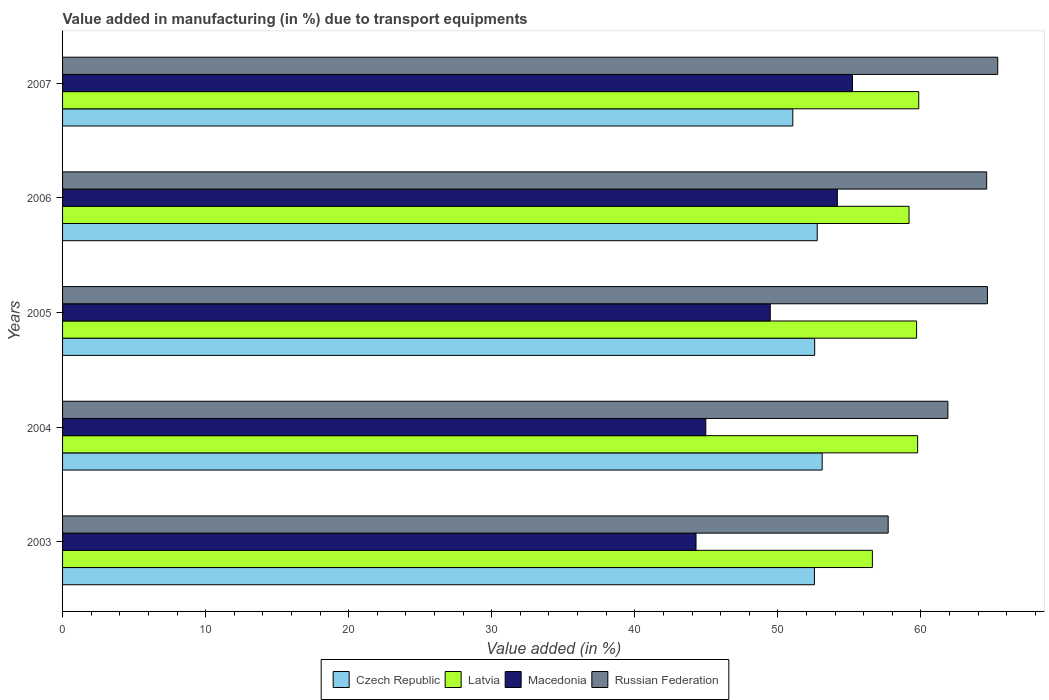How many different coloured bars are there?
Make the answer very short. 4. How many bars are there on the 2nd tick from the top?
Give a very brief answer. 4. How many bars are there on the 4th tick from the bottom?
Your response must be concise. 4. What is the label of the 2nd group of bars from the top?
Provide a succinct answer. 2006. What is the percentage of value added in manufacturing due to transport equipments in Russian Federation in 2005?
Make the answer very short. 64.65. Across all years, what is the maximum percentage of value added in manufacturing due to transport equipments in Russian Federation?
Your answer should be compact. 65.37. Across all years, what is the minimum percentage of value added in manufacturing due to transport equipments in Macedonia?
Your response must be concise. 44.28. In which year was the percentage of value added in manufacturing due to transport equipments in Czech Republic maximum?
Ensure brevity in your answer.  2004. In which year was the percentage of value added in manufacturing due to transport equipments in Russian Federation minimum?
Offer a very short reply. 2003. What is the total percentage of value added in manufacturing due to transport equipments in Russian Federation in the graph?
Provide a succinct answer. 314.21. What is the difference between the percentage of value added in manufacturing due to transport equipments in Russian Federation in 2003 and that in 2005?
Your answer should be compact. -6.94. What is the difference between the percentage of value added in manufacturing due to transport equipments in Russian Federation in 2005 and the percentage of value added in manufacturing due to transport equipments in Macedonia in 2003?
Ensure brevity in your answer.  20.37. What is the average percentage of value added in manufacturing due to transport equipments in Latvia per year?
Keep it short and to the point. 59.02. In the year 2007, what is the difference between the percentage of value added in manufacturing due to transport equipments in Russian Federation and percentage of value added in manufacturing due to transport equipments in Czech Republic?
Your response must be concise. 14.32. What is the ratio of the percentage of value added in manufacturing due to transport equipments in Czech Republic in 2005 to that in 2007?
Ensure brevity in your answer.  1.03. Is the percentage of value added in manufacturing due to transport equipments in Czech Republic in 2005 less than that in 2006?
Your response must be concise. Yes. Is the difference between the percentage of value added in manufacturing due to transport equipments in Russian Federation in 2006 and 2007 greater than the difference between the percentage of value added in manufacturing due to transport equipments in Czech Republic in 2006 and 2007?
Give a very brief answer. No. What is the difference between the highest and the second highest percentage of value added in manufacturing due to transport equipments in Czech Republic?
Your answer should be compact. 0.35. What is the difference between the highest and the lowest percentage of value added in manufacturing due to transport equipments in Czech Republic?
Ensure brevity in your answer.  2.05. Is the sum of the percentage of value added in manufacturing due to transport equipments in Latvia in 2003 and 2006 greater than the maximum percentage of value added in manufacturing due to transport equipments in Czech Republic across all years?
Ensure brevity in your answer.  Yes. What does the 4th bar from the top in 2003 represents?
Your answer should be very brief. Czech Republic. What does the 4th bar from the bottom in 2006 represents?
Your answer should be compact. Russian Federation. Is it the case that in every year, the sum of the percentage of value added in manufacturing due to transport equipments in Latvia and percentage of value added in manufacturing due to transport equipments in Russian Federation is greater than the percentage of value added in manufacturing due to transport equipments in Macedonia?
Offer a terse response. Yes. How many bars are there?
Offer a very short reply. 20. Are all the bars in the graph horizontal?
Offer a terse response. Yes. What is the difference between two consecutive major ticks on the X-axis?
Ensure brevity in your answer.  10. Does the graph contain any zero values?
Your answer should be very brief. No. Does the graph contain grids?
Offer a terse response. No. Where does the legend appear in the graph?
Your answer should be very brief. Bottom center. What is the title of the graph?
Your answer should be very brief. Value added in manufacturing (in %) due to transport equipments. Does "Liechtenstein" appear as one of the legend labels in the graph?
Ensure brevity in your answer.  No. What is the label or title of the X-axis?
Your response must be concise. Value added (in %). What is the Value added (in %) of Czech Republic in 2003?
Provide a succinct answer. 52.56. What is the Value added (in %) of Latvia in 2003?
Your answer should be compact. 56.61. What is the Value added (in %) of Macedonia in 2003?
Make the answer very short. 44.28. What is the Value added (in %) in Russian Federation in 2003?
Provide a succinct answer. 57.71. What is the Value added (in %) of Czech Republic in 2004?
Ensure brevity in your answer.  53.1. What is the Value added (in %) of Latvia in 2004?
Make the answer very short. 59.77. What is the Value added (in %) in Macedonia in 2004?
Give a very brief answer. 44.96. What is the Value added (in %) in Russian Federation in 2004?
Offer a terse response. 61.89. What is the Value added (in %) of Czech Republic in 2005?
Offer a very short reply. 52.57. What is the Value added (in %) of Latvia in 2005?
Offer a very short reply. 59.7. What is the Value added (in %) in Macedonia in 2005?
Your answer should be compact. 49.47. What is the Value added (in %) of Russian Federation in 2005?
Offer a very short reply. 64.65. What is the Value added (in %) in Czech Republic in 2006?
Ensure brevity in your answer.  52.75. What is the Value added (in %) of Latvia in 2006?
Offer a very short reply. 59.17. What is the Value added (in %) in Macedonia in 2006?
Your answer should be very brief. 54.16. What is the Value added (in %) in Russian Federation in 2006?
Keep it short and to the point. 64.59. What is the Value added (in %) in Czech Republic in 2007?
Ensure brevity in your answer.  51.04. What is the Value added (in %) of Latvia in 2007?
Ensure brevity in your answer.  59.85. What is the Value added (in %) in Macedonia in 2007?
Provide a succinct answer. 55.21. What is the Value added (in %) of Russian Federation in 2007?
Give a very brief answer. 65.37. Across all years, what is the maximum Value added (in %) of Czech Republic?
Offer a terse response. 53.1. Across all years, what is the maximum Value added (in %) in Latvia?
Provide a succinct answer. 59.85. Across all years, what is the maximum Value added (in %) in Macedonia?
Provide a short and direct response. 55.21. Across all years, what is the maximum Value added (in %) in Russian Federation?
Make the answer very short. 65.37. Across all years, what is the minimum Value added (in %) in Czech Republic?
Make the answer very short. 51.04. Across all years, what is the minimum Value added (in %) in Latvia?
Offer a terse response. 56.61. Across all years, what is the minimum Value added (in %) in Macedonia?
Offer a very short reply. 44.28. Across all years, what is the minimum Value added (in %) of Russian Federation?
Offer a very short reply. 57.71. What is the total Value added (in %) in Czech Republic in the graph?
Give a very brief answer. 262.02. What is the total Value added (in %) of Latvia in the graph?
Provide a short and direct response. 295.09. What is the total Value added (in %) in Macedonia in the graph?
Give a very brief answer. 248.08. What is the total Value added (in %) of Russian Federation in the graph?
Your answer should be very brief. 314.21. What is the difference between the Value added (in %) of Czech Republic in 2003 and that in 2004?
Make the answer very short. -0.54. What is the difference between the Value added (in %) of Latvia in 2003 and that in 2004?
Offer a terse response. -3.16. What is the difference between the Value added (in %) in Macedonia in 2003 and that in 2004?
Provide a short and direct response. -0.68. What is the difference between the Value added (in %) in Russian Federation in 2003 and that in 2004?
Make the answer very short. -4.18. What is the difference between the Value added (in %) in Czech Republic in 2003 and that in 2005?
Give a very brief answer. -0.02. What is the difference between the Value added (in %) of Latvia in 2003 and that in 2005?
Keep it short and to the point. -3.09. What is the difference between the Value added (in %) of Macedonia in 2003 and that in 2005?
Provide a short and direct response. -5.19. What is the difference between the Value added (in %) in Russian Federation in 2003 and that in 2005?
Keep it short and to the point. -6.94. What is the difference between the Value added (in %) in Czech Republic in 2003 and that in 2006?
Ensure brevity in your answer.  -0.19. What is the difference between the Value added (in %) in Latvia in 2003 and that in 2006?
Ensure brevity in your answer.  -2.56. What is the difference between the Value added (in %) of Macedonia in 2003 and that in 2006?
Provide a short and direct response. -9.88. What is the difference between the Value added (in %) in Russian Federation in 2003 and that in 2006?
Offer a very short reply. -6.88. What is the difference between the Value added (in %) of Czech Republic in 2003 and that in 2007?
Keep it short and to the point. 1.51. What is the difference between the Value added (in %) in Latvia in 2003 and that in 2007?
Provide a succinct answer. -3.24. What is the difference between the Value added (in %) in Macedonia in 2003 and that in 2007?
Give a very brief answer. -10.93. What is the difference between the Value added (in %) in Russian Federation in 2003 and that in 2007?
Give a very brief answer. -7.66. What is the difference between the Value added (in %) of Czech Republic in 2004 and that in 2005?
Your answer should be compact. 0.52. What is the difference between the Value added (in %) in Latvia in 2004 and that in 2005?
Your response must be concise. 0.07. What is the difference between the Value added (in %) in Macedonia in 2004 and that in 2005?
Make the answer very short. -4.51. What is the difference between the Value added (in %) of Russian Federation in 2004 and that in 2005?
Ensure brevity in your answer.  -2.76. What is the difference between the Value added (in %) in Czech Republic in 2004 and that in 2006?
Ensure brevity in your answer.  0.35. What is the difference between the Value added (in %) in Latvia in 2004 and that in 2006?
Provide a succinct answer. 0.6. What is the difference between the Value added (in %) of Macedonia in 2004 and that in 2006?
Offer a very short reply. -9.19. What is the difference between the Value added (in %) in Russian Federation in 2004 and that in 2006?
Provide a short and direct response. -2.71. What is the difference between the Value added (in %) of Czech Republic in 2004 and that in 2007?
Your response must be concise. 2.05. What is the difference between the Value added (in %) in Latvia in 2004 and that in 2007?
Give a very brief answer. -0.08. What is the difference between the Value added (in %) of Macedonia in 2004 and that in 2007?
Make the answer very short. -10.25. What is the difference between the Value added (in %) of Russian Federation in 2004 and that in 2007?
Offer a terse response. -3.48. What is the difference between the Value added (in %) of Czech Republic in 2005 and that in 2006?
Offer a very short reply. -0.18. What is the difference between the Value added (in %) of Latvia in 2005 and that in 2006?
Your answer should be very brief. 0.53. What is the difference between the Value added (in %) of Macedonia in 2005 and that in 2006?
Give a very brief answer. -4.69. What is the difference between the Value added (in %) in Russian Federation in 2005 and that in 2006?
Offer a very short reply. 0.05. What is the difference between the Value added (in %) of Czech Republic in 2005 and that in 2007?
Provide a succinct answer. 1.53. What is the difference between the Value added (in %) in Macedonia in 2005 and that in 2007?
Offer a very short reply. -5.75. What is the difference between the Value added (in %) in Russian Federation in 2005 and that in 2007?
Your answer should be compact. -0.72. What is the difference between the Value added (in %) of Czech Republic in 2006 and that in 2007?
Offer a terse response. 1.71. What is the difference between the Value added (in %) in Latvia in 2006 and that in 2007?
Your answer should be compact. -0.68. What is the difference between the Value added (in %) of Macedonia in 2006 and that in 2007?
Make the answer very short. -1.06. What is the difference between the Value added (in %) in Russian Federation in 2006 and that in 2007?
Provide a succinct answer. -0.77. What is the difference between the Value added (in %) in Czech Republic in 2003 and the Value added (in %) in Latvia in 2004?
Your response must be concise. -7.21. What is the difference between the Value added (in %) of Czech Republic in 2003 and the Value added (in %) of Macedonia in 2004?
Ensure brevity in your answer.  7.59. What is the difference between the Value added (in %) in Czech Republic in 2003 and the Value added (in %) in Russian Federation in 2004?
Make the answer very short. -9.33. What is the difference between the Value added (in %) of Latvia in 2003 and the Value added (in %) of Macedonia in 2004?
Ensure brevity in your answer.  11.64. What is the difference between the Value added (in %) of Latvia in 2003 and the Value added (in %) of Russian Federation in 2004?
Make the answer very short. -5.28. What is the difference between the Value added (in %) of Macedonia in 2003 and the Value added (in %) of Russian Federation in 2004?
Your answer should be very brief. -17.61. What is the difference between the Value added (in %) in Czech Republic in 2003 and the Value added (in %) in Latvia in 2005?
Make the answer very short. -7.14. What is the difference between the Value added (in %) in Czech Republic in 2003 and the Value added (in %) in Macedonia in 2005?
Provide a short and direct response. 3.09. What is the difference between the Value added (in %) of Czech Republic in 2003 and the Value added (in %) of Russian Federation in 2005?
Provide a short and direct response. -12.09. What is the difference between the Value added (in %) of Latvia in 2003 and the Value added (in %) of Macedonia in 2005?
Give a very brief answer. 7.14. What is the difference between the Value added (in %) in Latvia in 2003 and the Value added (in %) in Russian Federation in 2005?
Offer a very short reply. -8.04. What is the difference between the Value added (in %) in Macedonia in 2003 and the Value added (in %) in Russian Federation in 2005?
Offer a very short reply. -20.37. What is the difference between the Value added (in %) of Czech Republic in 2003 and the Value added (in %) of Latvia in 2006?
Your answer should be compact. -6.61. What is the difference between the Value added (in %) of Czech Republic in 2003 and the Value added (in %) of Macedonia in 2006?
Provide a succinct answer. -1.6. What is the difference between the Value added (in %) of Czech Republic in 2003 and the Value added (in %) of Russian Federation in 2006?
Offer a terse response. -12.04. What is the difference between the Value added (in %) in Latvia in 2003 and the Value added (in %) in Macedonia in 2006?
Your answer should be compact. 2.45. What is the difference between the Value added (in %) in Latvia in 2003 and the Value added (in %) in Russian Federation in 2006?
Your response must be concise. -7.99. What is the difference between the Value added (in %) in Macedonia in 2003 and the Value added (in %) in Russian Federation in 2006?
Your answer should be compact. -20.32. What is the difference between the Value added (in %) of Czech Republic in 2003 and the Value added (in %) of Latvia in 2007?
Your answer should be compact. -7.29. What is the difference between the Value added (in %) in Czech Republic in 2003 and the Value added (in %) in Macedonia in 2007?
Keep it short and to the point. -2.66. What is the difference between the Value added (in %) of Czech Republic in 2003 and the Value added (in %) of Russian Federation in 2007?
Your answer should be very brief. -12.81. What is the difference between the Value added (in %) in Latvia in 2003 and the Value added (in %) in Macedonia in 2007?
Give a very brief answer. 1.39. What is the difference between the Value added (in %) of Latvia in 2003 and the Value added (in %) of Russian Federation in 2007?
Offer a very short reply. -8.76. What is the difference between the Value added (in %) of Macedonia in 2003 and the Value added (in %) of Russian Federation in 2007?
Make the answer very short. -21.09. What is the difference between the Value added (in %) in Czech Republic in 2004 and the Value added (in %) in Latvia in 2005?
Keep it short and to the point. -6.6. What is the difference between the Value added (in %) in Czech Republic in 2004 and the Value added (in %) in Macedonia in 2005?
Your answer should be compact. 3.63. What is the difference between the Value added (in %) of Czech Republic in 2004 and the Value added (in %) of Russian Federation in 2005?
Keep it short and to the point. -11.55. What is the difference between the Value added (in %) in Latvia in 2004 and the Value added (in %) in Macedonia in 2005?
Keep it short and to the point. 10.3. What is the difference between the Value added (in %) of Latvia in 2004 and the Value added (in %) of Russian Federation in 2005?
Ensure brevity in your answer.  -4.88. What is the difference between the Value added (in %) in Macedonia in 2004 and the Value added (in %) in Russian Federation in 2005?
Make the answer very short. -19.68. What is the difference between the Value added (in %) of Czech Republic in 2004 and the Value added (in %) of Latvia in 2006?
Keep it short and to the point. -6.07. What is the difference between the Value added (in %) of Czech Republic in 2004 and the Value added (in %) of Macedonia in 2006?
Your answer should be very brief. -1.06. What is the difference between the Value added (in %) in Czech Republic in 2004 and the Value added (in %) in Russian Federation in 2006?
Offer a very short reply. -11.5. What is the difference between the Value added (in %) in Latvia in 2004 and the Value added (in %) in Macedonia in 2006?
Offer a very short reply. 5.61. What is the difference between the Value added (in %) of Latvia in 2004 and the Value added (in %) of Russian Federation in 2006?
Your answer should be very brief. -4.83. What is the difference between the Value added (in %) in Macedonia in 2004 and the Value added (in %) in Russian Federation in 2006?
Keep it short and to the point. -19.63. What is the difference between the Value added (in %) in Czech Republic in 2004 and the Value added (in %) in Latvia in 2007?
Your answer should be compact. -6.75. What is the difference between the Value added (in %) in Czech Republic in 2004 and the Value added (in %) in Macedonia in 2007?
Offer a very short reply. -2.12. What is the difference between the Value added (in %) of Czech Republic in 2004 and the Value added (in %) of Russian Federation in 2007?
Offer a terse response. -12.27. What is the difference between the Value added (in %) of Latvia in 2004 and the Value added (in %) of Macedonia in 2007?
Offer a very short reply. 4.56. What is the difference between the Value added (in %) in Latvia in 2004 and the Value added (in %) in Russian Federation in 2007?
Your answer should be compact. -5.6. What is the difference between the Value added (in %) of Macedonia in 2004 and the Value added (in %) of Russian Federation in 2007?
Make the answer very short. -20.41. What is the difference between the Value added (in %) in Czech Republic in 2005 and the Value added (in %) in Latvia in 2006?
Your response must be concise. -6.6. What is the difference between the Value added (in %) in Czech Republic in 2005 and the Value added (in %) in Macedonia in 2006?
Your response must be concise. -1.58. What is the difference between the Value added (in %) in Czech Republic in 2005 and the Value added (in %) in Russian Federation in 2006?
Offer a very short reply. -12.02. What is the difference between the Value added (in %) of Latvia in 2005 and the Value added (in %) of Macedonia in 2006?
Your response must be concise. 5.54. What is the difference between the Value added (in %) of Latvia in 2005 and the Value added (in %) of Russian Federation in 2006?
Provide a succinct answer. -4.9. What is the difference between the Value added (in %) in Macedonia in 2005 and the Value added (in %) in Russian Federation in 2006?
Provide a short and direct response. -15.13. What is the difference between the Value added (in %) in Czech Republic in 2005 and the Value added (in %) in Latvia in 2007?
Provide a succinct answer. -7.27. What is the difference between the Value added (in %) in Czech Republic in 2005 and the Value added (in %) in Macedonia in 2007?
Give a very brief answer. -2.64. What is the difference between the Value added (in %) in Czech Republic in 2005 and the Value added (in %) in Russian Federation in 2007?
Keep it short and to the point. -12.79. What is the difference between the Value added (in %) of Latvia in 2005 and the Value added (in %) of Macedonia in 2007?
Ensure brevity in your answer.  4.48. What is the difference between the Value added (in %) of Latvia in 2005 and the Value added (in %) of Russian Federation in 2007?
Your answer should be very brief. -5.67. What is the difference between the Value added (in %) of Macedonia in 2005 and the Value added (in %) of Russian Federation in 2007?
Keep it short and to the point. -15.9. What is the difference between the Value added (in %) of Czech Republic in 2006 and the Value added (in %) of Latvia in 2007?
Your answer should be compact. -7.1. What is the difference between the Value added (in %) of Czech Republic in 2006 and the Value added (in %) of Macedonia in 2007?
Make the answer very short. -2.46. What is the difference between the Value added (in %) of Czech Republic in 2006 and the Value added (in %) of Russian Federation in 2007?
Provide a succinct answer. -12.62. What is the difference between the Value added (in %) of Latvia in 2006 and the Value added (in %) of Macedonia in 2007?
Your response must be concise. 3.96. What is the difference between the Value added (in %) of Latvia in 2006 and the Value added (in %) of Russian Federation in 2007?
Make the answer very short. -6.2. What is the difference between the Value added (in %) of Macedonia in 2006 and the Value added (in %) of Russian Federation in 2007?
Keep it short and to the point. -11.21. What is the average Value added (in %) in Czech Republic per year?
Your answer should be very brief. 52.4. What is the average Value added (in %) of Latvia per year?
Ensure brevity in your answer.  59.02. What is the average Value added (in %) in Macedonia per year?
Ensure brevity in your answer.  49.62. What is the average Value added (in %) of Russian Federation per year?
Make the answer very short. 62.84. In the year 2003, what is the difference between the Value added (in %) in Czech Republic and Value added (in %) in Latvia?
Provide a short and direct response. -4.05. In the year 2003, what is the difference between the Value added (in %) of Czech Republic and Value added (in %) of Macedonia?
Make the answer very short. 8.28. In the year 2003, what is the difference between the Value added (in %) of Czech Republic and Value added (in %) of Russian Federation?
Keep it short and to the point. -5.15. In the year 2003, what is the difference between the Value added (in %) of Latvia and Value added (in %) of Macedonia?
Your answer should be very brief. 12.33. In the year 2003, what is the difference between the Value added (in %) in Latvia and Value added (in %) in Russian Federation?
Offer a very short reply. -1.1. In the year 2003, what is the difference between the Value added (in %) of Macedonia and Value added (in %) of Russian Federation?
Offer a very short reply. -13.43. In the year 2004, what is the difference between the Value added (in %) of Czech Republic and Value added (in %) of Latvia?
Provide a succinct answer. -6.67. In the year 2004, what is the difference between the Value added (in %) of Czech Republic and Value added (in %) of Macedonia?
Your answer should be compact. 8.13. In the year 2004, what is the difference between the Value added (in %) in Czech Republic and Value added (in %) in Russian Federation?
Your answer should be very brief. -8.79. In the year 2004, what is the difference between the Value added (in %) of Latvia and Value added (in %) of Macedonia?
Make the answer very short. 14.81. In the year 2004, what is the difference between the Value added (in %) in Latvia and Value added (in %) in Russian Federation?
Make the answer very short. -2.12. In the year 2004, what is the difference between the Value added (in %) of Macedonia and Value added (in %) of Russian Federation?
Provide a short and direct response. -16.92. In the year 2005, what is the difference between the Value added (in %) of Czech Republic and Value added (in %) of Latvia?
Keep it short and to the point. -7.12. In the year 2005, what is the difference between the Value added (in %) in Czech Republic and Value added (in %) in Macedonia?
Offer a very short reply. 3.11. In the year 2005, what is the difference between the Value added (in %) of Czech Republic and Value added (in %) of Russian Federation?
Offer a terse response. -12.07. In the year 2005, what is the difference between the Value added (in %) in Latvia and Value added (in %) in Macedonia?
Your answer should be compact. 10.23. In the year 2005, what is the difference between the Value added (in %) in Latvia and Value added (in %) in Russian Federation?
Provide a succinct answer. -4.95. In the year 2005, what is the difference between the Value added (in %) of Macedonia and Value added (in %) of Russian Federation?
Offer a very short reply. -15.18. In the year 2006, what is the difference between the Value added (in %) in Czech Republic and Value added (in %) in Latvia?
Offer a very short reply. -6.42. In the year 2006, what is the difference between the Value added (in %) of Czech Republic and Value added (in %) of Macedonia?
Your answer should be compact. -1.41. In the year 2006, what is the difference between the Value added (in %) in Czech Republic and Value added (in %) in Russian Federation?
Make the answer very short. -11.85. In the year 2006, what is the difference between the Value added (in %) in Latvia and Value added (in %) in Macedonia?
Ensure brevity in your answer.  5.01. In the year 2006, what is the difference between the Value added (in %) of Latvia and Value added (in %) of Russian Federation?
Make the answer very short. -5.43. In the year 2006, what is the difference between the Value added (in %) in Macedonia and Value added (in %) in Russian Federation?
Your answer should be compact. -10.44. In the year 2007, what is the difference between the Value added (in %) of Czech Republic and Value added (in %) of Latvia?
Your answer should be very brief. -8.8. In the year 2007, what is the difference between the Value added (in %) in Czech Republic and Value added (in %) in Macedonia?
Provide a short and direct response. -4.17. In the year 2007, what is the difference between the Value added (in %) in Czech Republic and Value added (in %) in Russian Federation?
Your answer should be very brief. -14.32. In the year 2007, what is the difference between the Value added (in %) in Latvia and Value added (in %) in Macedonia?
Offer a terse response. 4.63. In the year 2007, what is the difference between the Value added (in %) of Latvia and Value added (in %) of Russian Federation?
Make the answer very short. -5.52. In the year 2007, what is the difference between the Value added (in %) in Macedonia and Value added (in %) in Russian Federation?
Provide a succinct answer. -10.15. What is the ratio of the Value added (in %) of Latvia in 2003 to that in 2004?
Offer a terse response. 0.95. What is the ratio of the Value added (in %) in Macedonia in 2003 to that in 2004?
Provide a succinct answer. 0.98. What is the ratio of the Value added (in %) of Russian Federation in 2003 to that in 2004?
Your response must be concise. 0.93. What is the ratio of the Value added (in %) in Latvia in 2003 to that in 2005?
Offer a terse response. 0.95. What is the ratio of the Value added (in %) in Macedonia in 2003 to that in 2005?
Ensure brevity in your answer.  0.9. What is the ratio of the Value added (in %) in Russian Federation in 2003 to that in 2005?
Ensure brevity in your answer.  0.89. What is the ratio of the Value added (in %) of Czech Republic in 2003 to that in 2006?
Give a very brief answer. 1. What is the ratio of the Value added (in %) in Latvia in 2003 to that in 2006?
Keep it short and to the point. 0.96. What is the ratio of the Value added (in %) of Macedonia in 2003 to that in 2006?
Your answer should be very brief. 0.82. What is the ratio of the Value added (in %) in Russian Federation in 2003 to that in 2006?
Your answer should be compact. 0.89. What is the ratio of the Value added (in %) of Czech Republic in 2003 to that in 2007?
Offer a terse response. 1.03. What is the ratio of the Value added (in %) of Latvia in 2003 to that in 2007?
Your response must be concise. 0.95. What is the ratio of the Value added (in %) of Macedonia in 2003 to that in 2007?
Your answer should be very brief. 0.8. What is the ratio of the Value added (in %) of Russian Federation in 2003 to that in 2007?
Your answer should be very brief. 0.88. What is the ratio of the Value added (in %) in Latvia in 2004 to that in 2005?
Offer a very short reply. 1. What is the ratio of the Value added (in %) in Macedonia in 2004 to that in 2005?
Provide a succinct answer. 0.91. What is the ratio of the Value added (in %) of Russian Federation in 2004 to that in 2005?
Make the answer very short. 0.96. What is the ratio of the Value added (in %) in Czech Republic in 2004 to that in 2006?
Provide a succinct answer. 1.01. What is the ratio of the Value added (in %) in Latvia in 2004 to that in 2006?
Your answer should be compact. 1.01. What is the ratio of the Value added (in %) of Macedonia in 2004 to that in 2006?
Your response must be concise. 0.83. What is the ratio of the Value added (in %) in Russian Federation in 2004 to that in 2006?
Provide a succinct answer. 0.96. What is the ratio of the Value added (in %) of Czech Republic in 2004 to that in 2007?
Your response must be concise. 1.04. What is the ratio of the Value added (in %) of Macedonia in 2004 to that in 2007?
Ensure brevity in your answer.  0.81. What is the ratio of the Value added (in %) in Russian Federation in 2004 to that in 2007?
Provide a succinct answer. 0.95. What is the ratio of the Value added (in %) in Latvia in 2005 to that in 2006?
Provide a succinct answer. 1.01. What is the ratio of the Value added (in %) of Macedonia in 2005 to that in 2006?
Your answer should be compact. 0.91. What is the ratio of the Value added (in %) of Russian Federation in 2005 to that in 2006?
Offer a very short reply. 1. What is the ratio of the Value added (in %) in Latvia in 2005 to that in 2007?
Offer a very short reply. 1. What is the ratio of the Value added (in %) of Macedonia in 2005 to that in 2007?
Your answer should be very brief. 0.9. What is the ratio of the Value added (in %) of Czech Republic in 2006 to that in 2007?
Offer a very short reply. 1.03. What is the ratio of the Value added (in %) in Latvia in 2006 to that in 2007?
Your response must be concise. 0.99. What is the ratio of the Value added (in %) of Macedonia in 2006 to that in 2007?
Make the answer very short. 0.98. What is the difference between the highest and the second highest Value added (in %) in Czech Republic?
Your answer should be compact. 0.35. What is the difference between the highest and the second highest Value added (in %) of Latvia?
Your answer should be compact. 0.08. What is the difference between the highest and the second highest Value added (in %) of Macedonia?
Provide a succinct answer. 1.06. What is the difference between the highest and the second highest Value added (in %) in Russian Federation?
Ensure brevity in your answer.  0.72. What is the difference between the highest and the lowest Value added (in %) in Czech Republic?
Keep it short and to the point. 2.05. What is the difference between the highest and the lowest Value added (in %) of Latvia?
Your answer should be compact. 3.24. What is the difference between the highest and the lowest Value added (in %) of Macedonia?
Keep it short and to the point. 10.93. What is the difference between the highest and the lowest Value added (in %) in Russian Federation?
Provide a succinct answer. 7.66. 